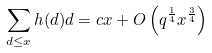Convert formula to latex. <formula><loc_0><loc_0><loc_500><loc_500>\sum _ { d \leq x } h ( d ) d = c x + O \left ( q ^ { \frac { 1 } { 4 } } x ^ { \frac { 3 } { 4 } } \right )</formula> 